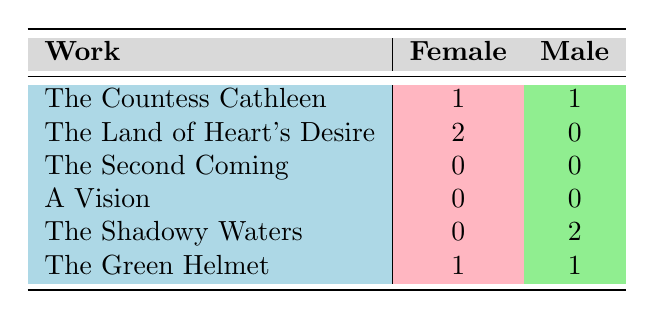What is the total number of female characters in Yeats's works listed? By adding the values in the "Female" column, we find that there are 1 (The Countess Cathleen) + 2 (The Land of Heart's Desire) + 0 (The Second Coming) + 0 (A Vision) + 0 (The Shadowy Waters) + 1 (The Green Helmet) = 4 female characters.
Answer: 4 How many works feature male characters and what is the total count of these male characters? The works that feature male characters are: The Countess Cathleen (1), The Shadowy Waters (2), and The Green Helmet (1), making a total of 4 male characters (1 + 2 + 1).
Answer: 4 Is there a work that has exclusively female characters? The Land of Heart's Desire has 2 female characters and 0 male characters, which qualifies it as the only work listed with exclusively female characters.
Answer: Yes Which work has the highest number of female characters? By comparing the number of female characters across works: The Countess Cathleen (1), The Land of Heart's Desire (2), The Second Coming (0), A Vision (0), The Shadowy Waters (0), and The Green Helmet (1), we find that The Land of Heart's Desire has the highest count of 2 female characters.
Answer: The Land of Heart's Desire What is the difference in the number of male and female characters in The Shadowy Waters? The Shadowy Waters has 0 female characters and 2 male characters. Thus, the difference is calculated as 2 (male) - 0 (female) = 2.
Answer: 2 Does The Green Helmet have an equal number of male and female characters? The Green Helmet has 1 male character and 1 female character, indicating that the counts are equal.
Answer: Yes What is the total number of characters across all works provided? Adding the total number of characters: (The Countess Cathleen has 2, The Land of Heart's Desire has 2, The Second Coming has 0, A Vision has 0, The Shadowy Waters has 2, and The Green Helmet has 2) gives us 2 + 2 + 0 + 0 + 2 + 2 = 8 characters in total.
Answer: 8 Which work has more male characters than female characters? Comparing the counts, The Shadowy Waters (0 female, 2 male) has more male characters than female characters. The other works either have equal or fewer male characters.
Answer: The Shadowy Waters 